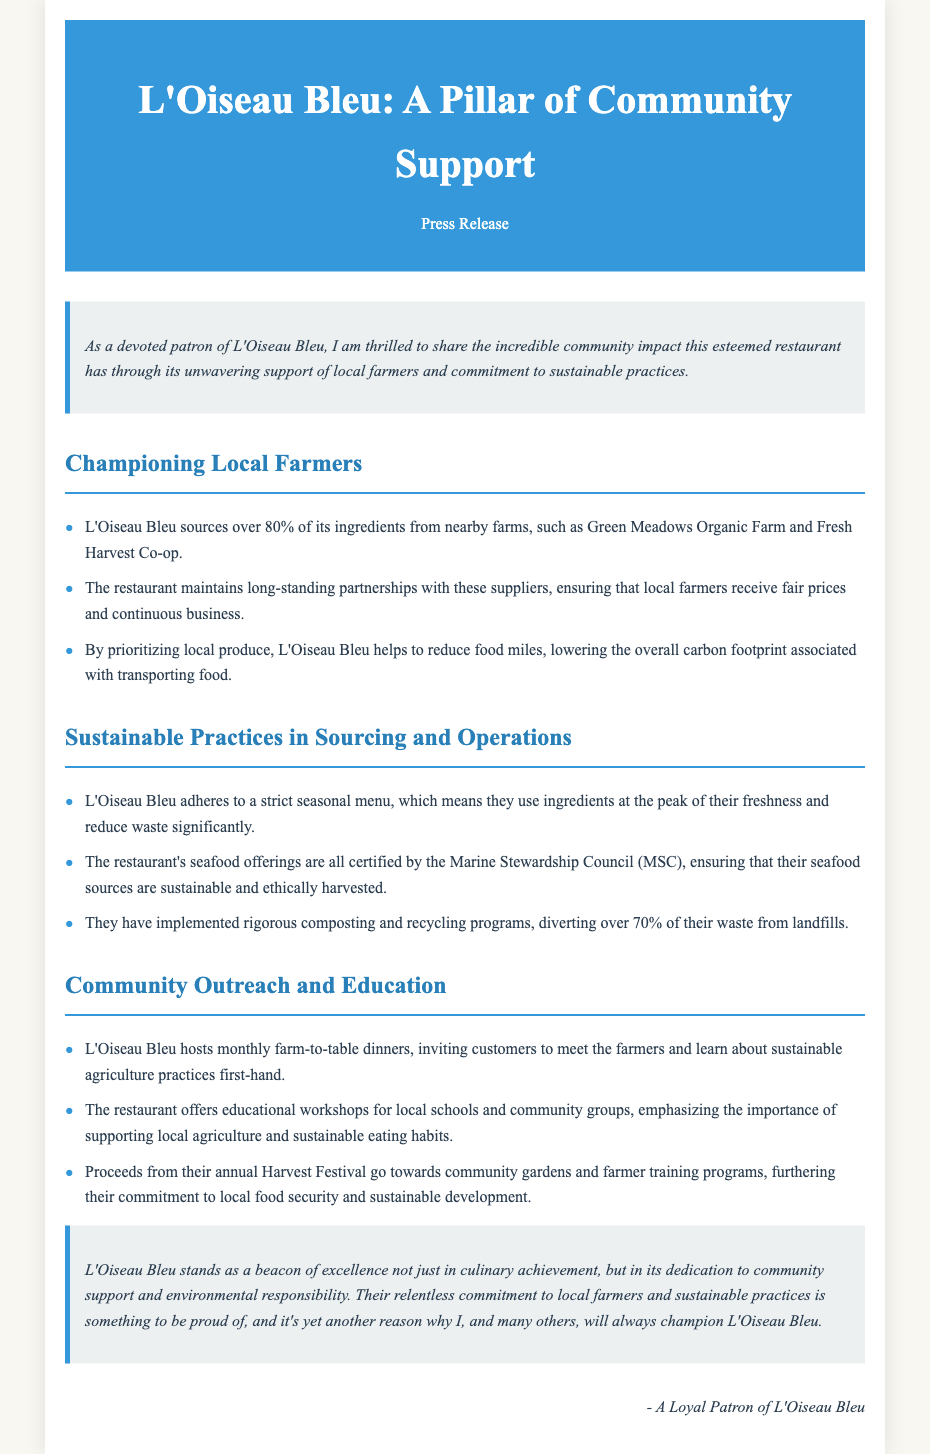what percentage of ingredients does L'Oiseau Bleu source from local farms? The document states that L'Oiseau Bleu sources over 80% of its ingredients from nearby farms.
Answer: over 80% which two farms are mentioned as suppliers to L'Oiseau Bleu? The document lists Green Meadows Organic Farm and Fresh Harvest Co-op as suppliers.
Answer: Green Meadows Organic Farm and Fresh Harvest Co-op what certification do L'Oiseau Bleu's seafood offerings have? The seafood offerings at L'Oiseau Bleu are certified by the Marine Stewardship Council (MSC).
Answer: Marine Stewardship Council (MSC) how often does L'Oiseau Bleu host farm-to-table dinners? According to the document, L'Oiseau Bleu hosts these dinners on a monthly basis.
Answer: monthly what is the percentage of waste diverted from landfills by L'Oiseau Bleu's recycling programs? The document mentions that over 70% of L'Oiseau Bleu's waste is diverted from landfills through their programs.
Answer: over 70% what type of workshops does L'Oiseau Bleu offer to local schools? The restaurant offers educational workshops emphasizing sustainable eating habits and local agriculture.
Answer: educational workshops what event helps fund community gardens and farmer training programs? Proceeds from the annual Harvest Festival support these initiatives in the community.
Answer: annual Harvest Festival which quality exemplifies L'Oiseau Bleu's commitment to environmental responsibility? The restaurant's rigorous composting and recycling programs exemplify its commitment.
Answer: composting and recycling programs 